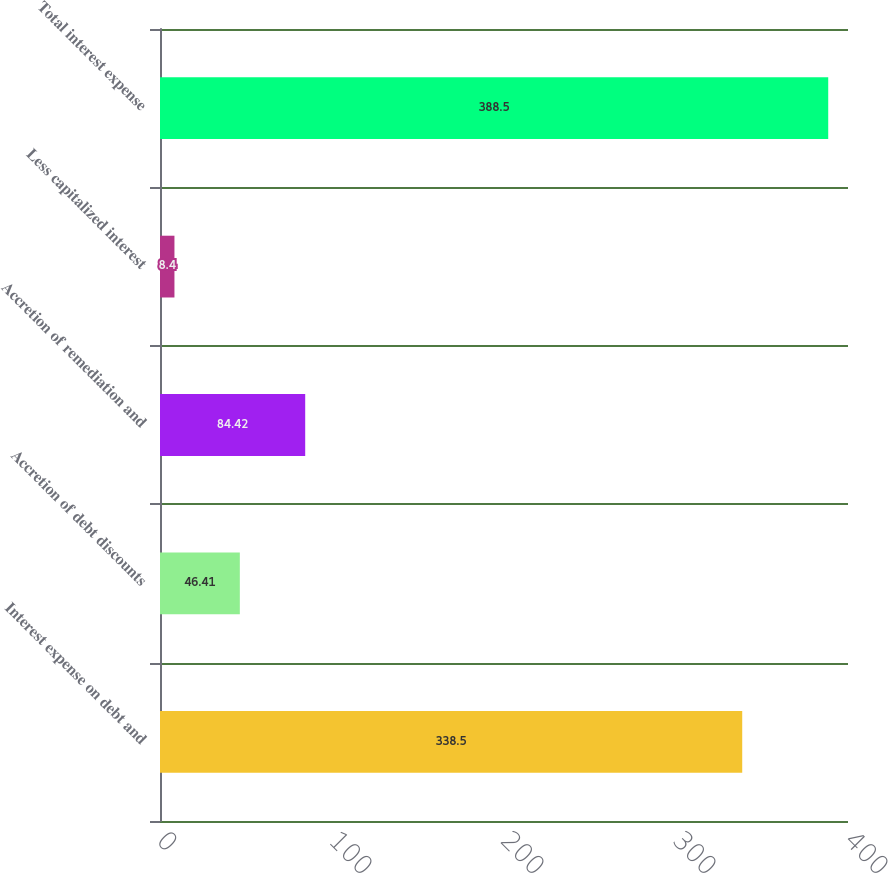Convert chart. <chart><loc_0><loc_0><loc_500><loc_500><bar_chart><fcel>Interest expense on debt and<fcel>Accretion of debt discounts<fcel>Accretion of remediation and<fcel>Less capitalized interest<fcel>Total interest expense<nl><fcel>338.5<fcel>46.41<fcel>84.42<fcel>8.4<fcel>388.5<nl></chart> 